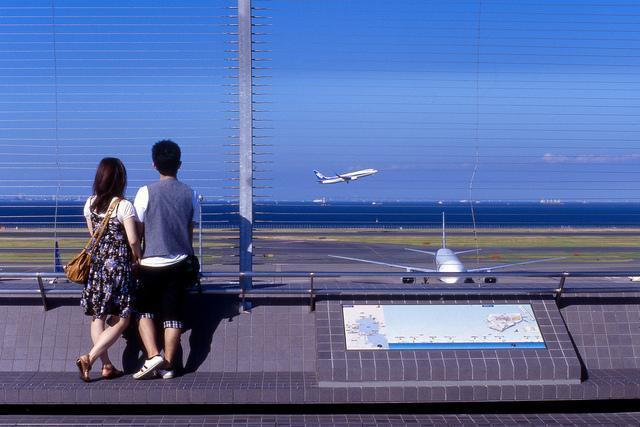How many people are there?
Give a very brief answer. 2. 